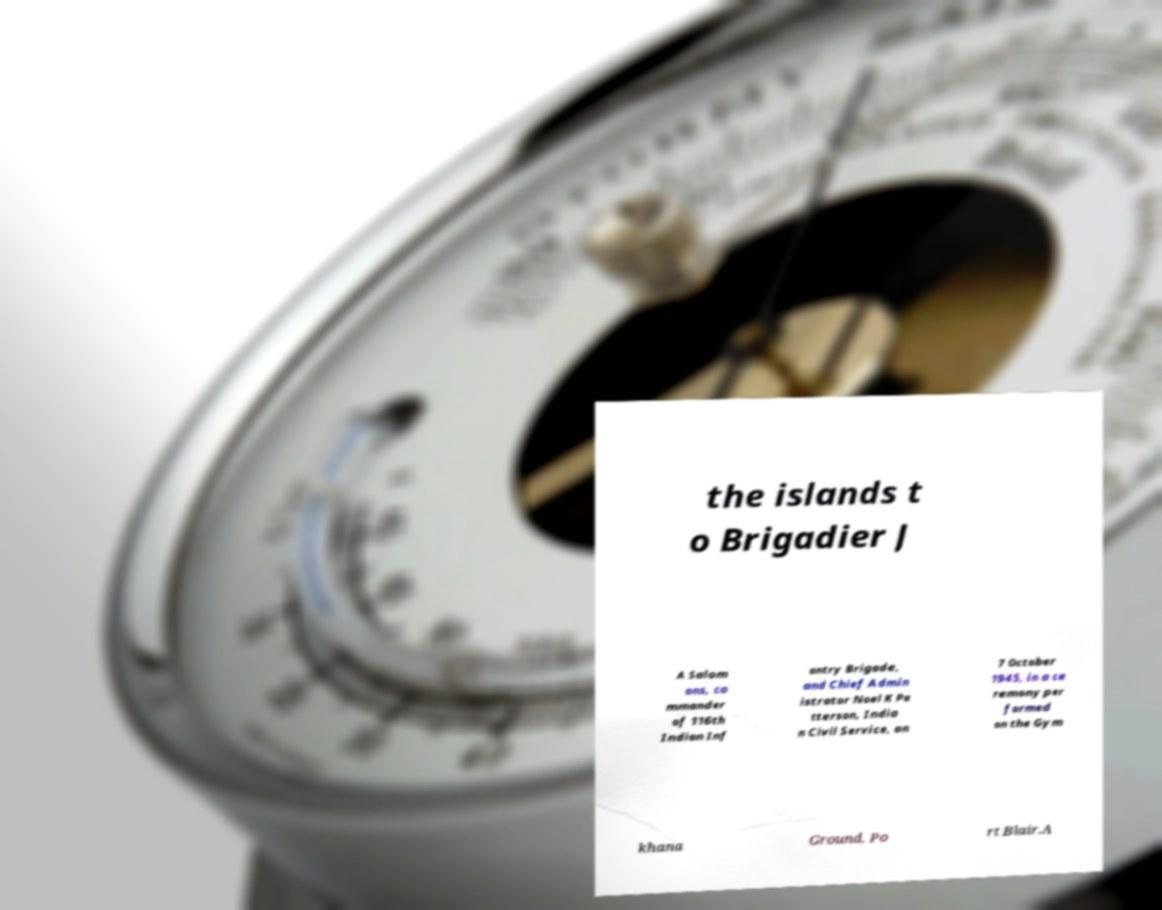What messages or text are displayed in this image? I need them in a readable, typed format. the islands t o Brigadier J A Salom ons, co mmander of 116th Indian Inf antry Brigade, and Chief Admin istrator Noel K Pa tterson, India n Civil Service, on 7 October 1945, in a ce remony per formed on the Gym khana Ground, Po rt Blair.A 